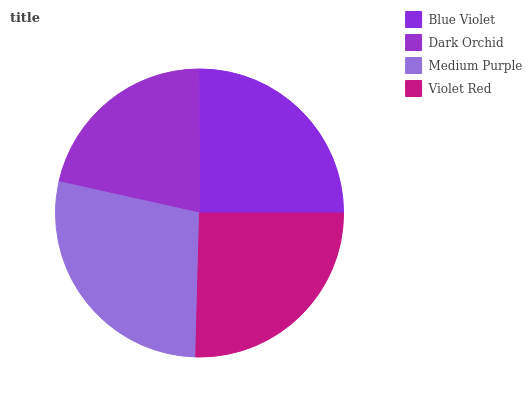Is Dark Orchid the minimum?
Answer yes or no. Yes. Is Medium Purple the maximum?
Answer yes or no. Yes. Is Medium Purple the minimum?
Answer yes or no. No. Is Dark Orchid the maximum?
Answer yes or no. No. Is Medium Purple greater than Dark Orchid?
Answer yes or no. Yes. Is Dark Orchid less than Medium Purple?
Answer yes or no. Yes. Is Dark Orchid greater than Medium Purple?
Answer yes or no. No. Is Medium Purple less than Dark Orchid?
Answer yes or no. No. Is Violet Red the high median?
Answer yes or no. Yes. Is Blue Violet the low median?
Answer yes or no. Yes. Is Dark Orchid the high median?
Answer yes or no. No. Is Violet Red the low median?
Answer yes or no. No. 